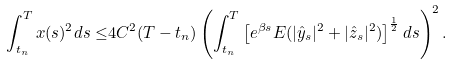Convert formula to latex. <formula><loc_0><loc_0><loc_500><loc_500>\int _ { t _ { n } } ^ { T } x ( s ) ^ { 2 } d s \leq & 4 C ^ { 2 } ( T - t _ { n } ) \left ( \int _ { t _ { n } } ^ { T } \left [ e ^ { \beta s } E ( | \hat { y } _ { s } | ^ { 2 } + | \hat { z } _ { s } | ^ { 2 } ) \right ] ^ { \frac { 1 } { 2 } } d s \right ) ^ { 2 } .</formula> 